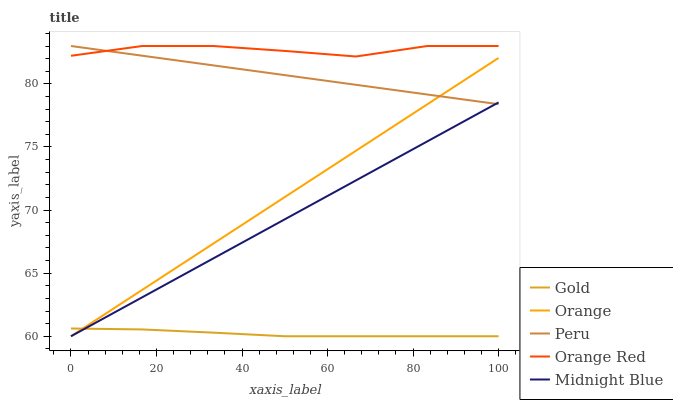Does Gold have the minimum area under the curve?
Answer yes or no. Yes. Does Orange Red have the maximum area under the curve?
Answer yes or no. Yes. Does Midnight Blue have the minimum area under the curve?
Answer yes or no. No. Does Midnight Blue have the maximum area under the curve?
Answer yes or no. No. Is Midnight Blue the smoothest?
Answer yes or no. Yes. Is Orange Red the roughest?
Answer yes or no. Yes. Is Peru the smoothest?
Answer yes or no. No. Is Peru the roughest?
Answer yes or no. No. Does Orange have the lowest value?
Answer yes or no. Yes. Does Peru have the lowest value?
Answer yes or no. No. Does Orange Red have the highest value?
Answer yes or no. Yes. Does Midnight Blue have the highest value?
Answer yes or no. No. Is Orange less than Orange Red?
Answer yes or no. Yes. Is Orange Red greater than Gold?
Answer yes or no. Yes. Does Midnight Blue intersect Orange?
Answer yes or no. Yes. Is Midnight Blue less than Orange?
Answer yes or no. No. Is Midnight Blue greater than Orange?
Answer yes or no. No. Does Orange intersect Orange Red?
Answer yes or no. No. 